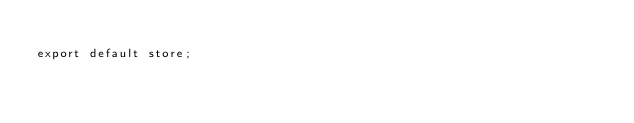Convert code to text. <code><loc_0><loc_0><loc_500><loc_500><_JavaScript_>
export default store;
</code> 